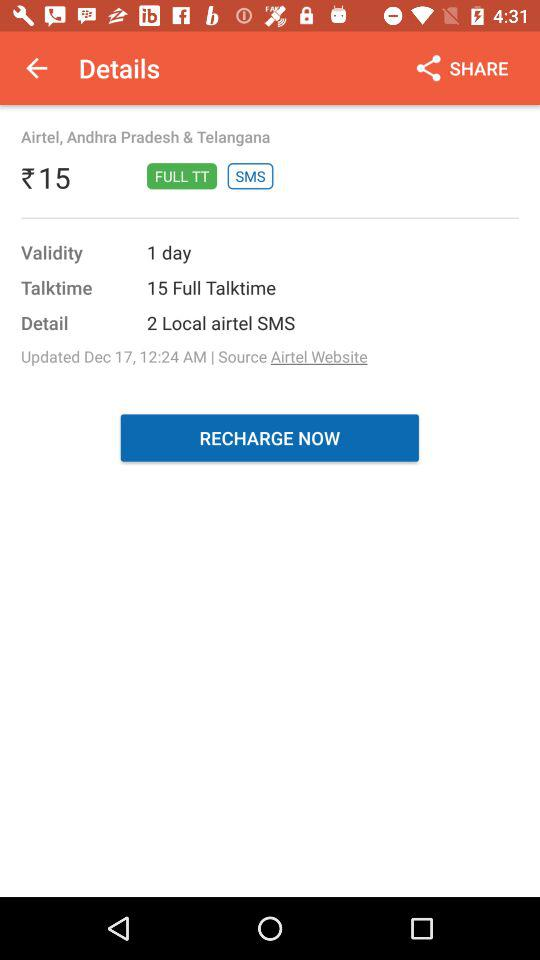When were the details updated? The details were updated on December 17 at 12:24 a.m. 